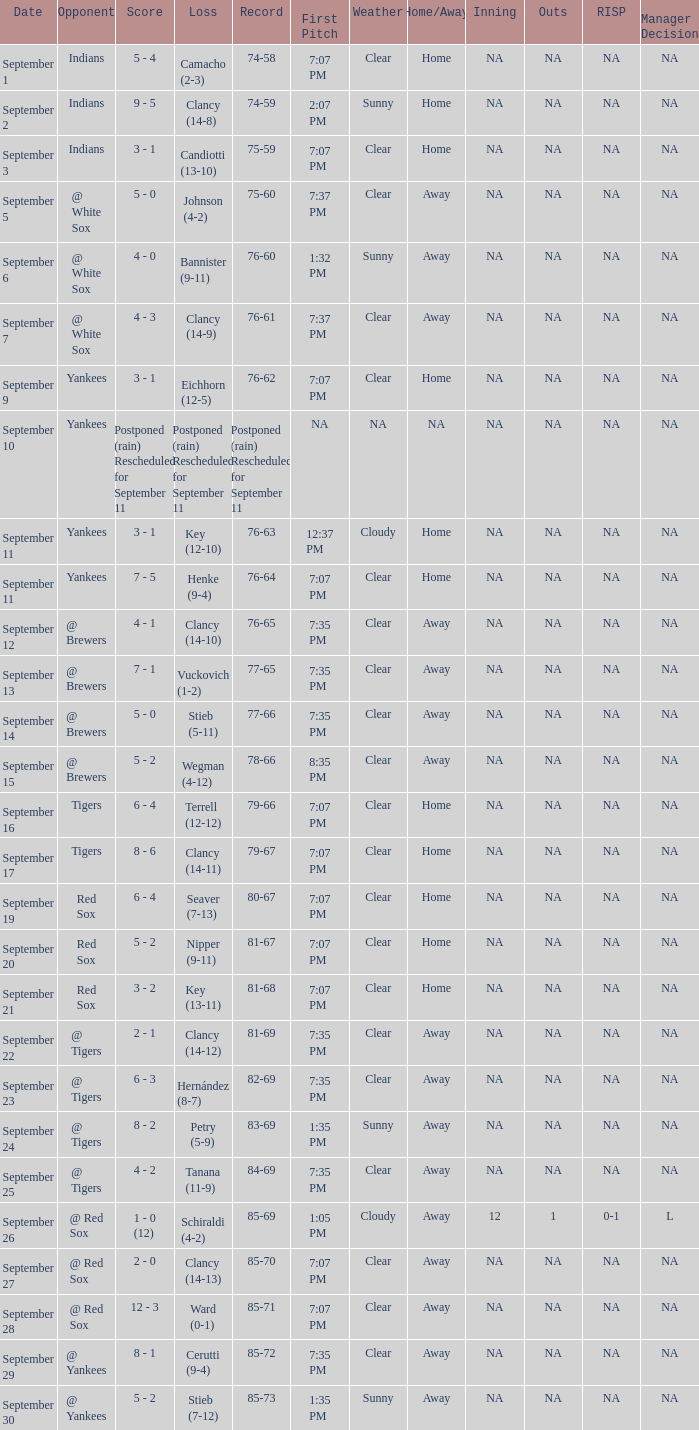Who was the Blue Jays opponent when their record was 84-69? @ Tigers. 